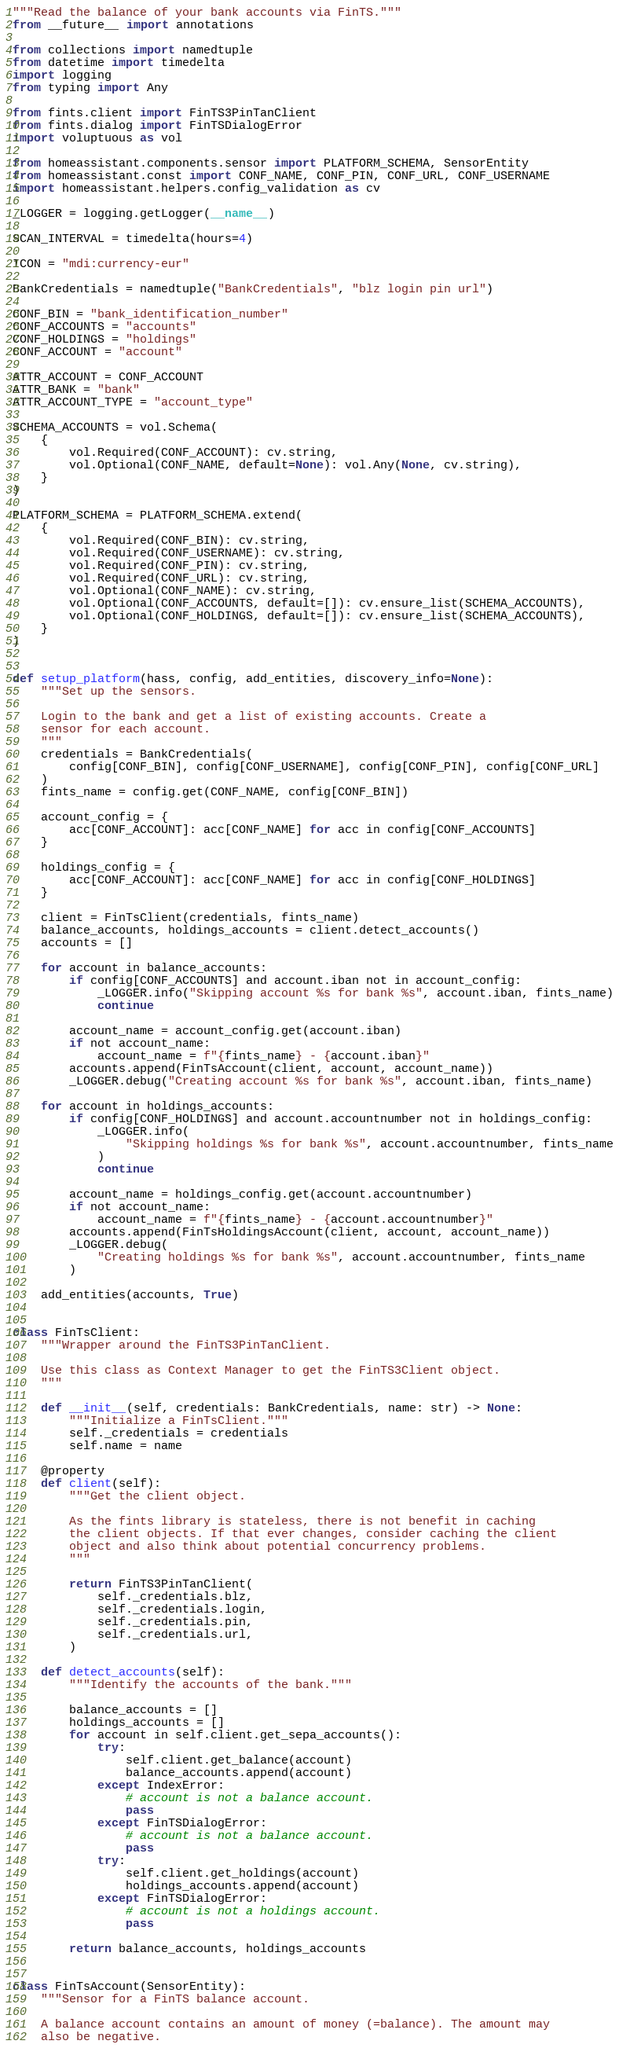<code> <loc_0><loc_0><loc_500><loc_500><_Python_>"""Read the balance of your bank accounts via FinTS."""
from __future__ import annotations

from collections import namedtuple
from datetime import timedelta
import logging
from typing import Any

from fints.client import FinTS3PinTanClient
from fints.dialog import FinTSDialogError
import voluptuous as vol

from homeassistant.components.sensor import PLATFORM_SCHEMA, SensorEntity
from homeassistant.const import CONF_NAME, CONF_PIN, CONF_URL, CONF_USERNAME
import homeassistant.helpers.config_validation as cv

_LOGGER = logging.getLogger(__name__)

SCAN_INTERVAL = timedelta(hours=4)

ICON = "mdi:currency-eur"

BankCredentials = namedtuple("BankCredentials", "blz login pin url")

CONF_BIN = "bank_identification_number"
CONF_ACCOUNTS = "accounts"
CONF_HOLDINGS = "holdings"
CONF_ACCOUNT = "account"

ATTR_ACCOUNT = CONF_ACCOUNT
ATTR_BANK = "bank"
ATTR_ACCOUNT_TYPE = "account_type"

SCHEMA_ACCOUNTS = vol.Schema(
    {
        vol.Required(CONF_ACCOUNT): cv.string,
        vol.Optional(CONF_NAME, default=None): vol.Any(None, cv.string),
    }
)

PLATFORM_SCHEMA = PLATFORM_SCHEMA.extend(
    {
        vol.Required(CONF_BIN): cv.string,
        vol.Required(CONF_USERNAME): cv.string,
        vol.Required(CONF_PIN): cv.string,
        vol.Required(CONF_URL): cv.string,
        vol.Optional(CONF_NAME): cv.string,
        vol.Optional(CONF_ACCOUNTS, default=[]): cv.ensure_list(SCHEMA_ACCOUNTS),
        vol.Optional(CONF_HOLDINGS, default=[]): cv.ensure_list(SCHEMA_ACCOUNTS),
    }
)


def setup_platform(hass, config, add_entities, discovery_info=None):
    """Set up the sensors.

    Login to the bank and get a list of existing accounts. Create a
    sensor for each account.
    """
    credentials = BankCredentials(
        config[CONF_BIN], config[CONF_USERNAME], config[CONF_PIN], config[CONF_URL]
    )
    fints_name = config.get(CONF_NAME, config[CONF_BIN])

    account_config = {
        acc[CONF_ACCOUNT]: acc[CONF_NAME] for acc in config[CONF_ACCOUNTS]
    }

    holdings_config = {
        acc[CONF_ACCOUNT]: acc[CONF_NAME] for acc in config[CONF_HOLDINGS]
    }

    client = FinTsClient(credentials, fints_name)
    balance_accounts, holdings_accounts = client.detect_accounts()
    accounts = []

    for account in balance_accounts:
        if config[CONF_ACCOUNTS] and account.iban not in account_config:
            _LOGGER.info("Skipping account %s for bank %s", account.iban, fints_name)
            continue

        account_name = account_config.get(account.iban)
        if not account_name:
            account_name = f"{fints_name} - {account.iban}"
        accounts.append(FinTsAccount(client, account, account_name))
        _LOGGER.debug("Creating account %s for bank %s", account.iban, fints_name)

    for account in holdings_accounts:
        if config[CONF_HOLDINGS] and account.accountnumber not in holdings_config:
            _LOGGER.info(
                "Skipping holdings %s for bank %s", account.accountnumber, fints_name
            )
            continue

        account_name = holdings_config.get(account.accountnumber)
        if not account_name:
            account_name = f"{fints_name} - {account.accountnumber}"
        accounts.append(FinTsHoldingsAccount(client, account, account_name))
        _LOGGER.debug(
            "Creating holdings %s for bank %s", account.accountnumber, fints_name
        )

    add_entities(accounts, True)


class FinTsClient:
    """Wrapper around the FinTS3PinTanClient.

    Use this class as Context Manager to get the FinTS3Client object.
    """

    def __init__(self, credentials: BankCredentials, name: str) -> None:
        """Initialize a FinTsClient."""
        self._credentials = credentials
        self.name = name

    @property
    def client(self):
        """Get the client object.

        As the fints library is stateless, there is not benefit in caching
        the client objects. If that ever changes, consider caching the client
        object and also think about potential concurrency problems.
        """

        return FinTS3PinTanClient(
            self._credentials.blz,
            self._credentials.login,
            self._credentials.pin,
            self._credentials.url,
        )

    def detect_accounts(self):
        """Identify the accounts of the bank."""

        balance_accounts = []
        holdings_accounts = []
        for account in self.client.get_sepa_accounts():
            try:
                self.client.get_balance(account)
                balance_accounts.append(account)
            except IndexError:
                # account is not a balance account.
                pass
            except FinTSDialogError:
                # account is not a balance account.
                pass
            try:
                self.client.get_holdings(account)
                holdings_accounts.append(account)
            except FinTSDialogError:
                # account is not a holdings account.
                pass

        return balance_accounts, holdings_accounts


class FinTsAccount(SensorEntity):
    """Sensor for a FinTS balance account.

    A balance account contains an amount of money (=balance). The amount may
    also be negative.</code> 